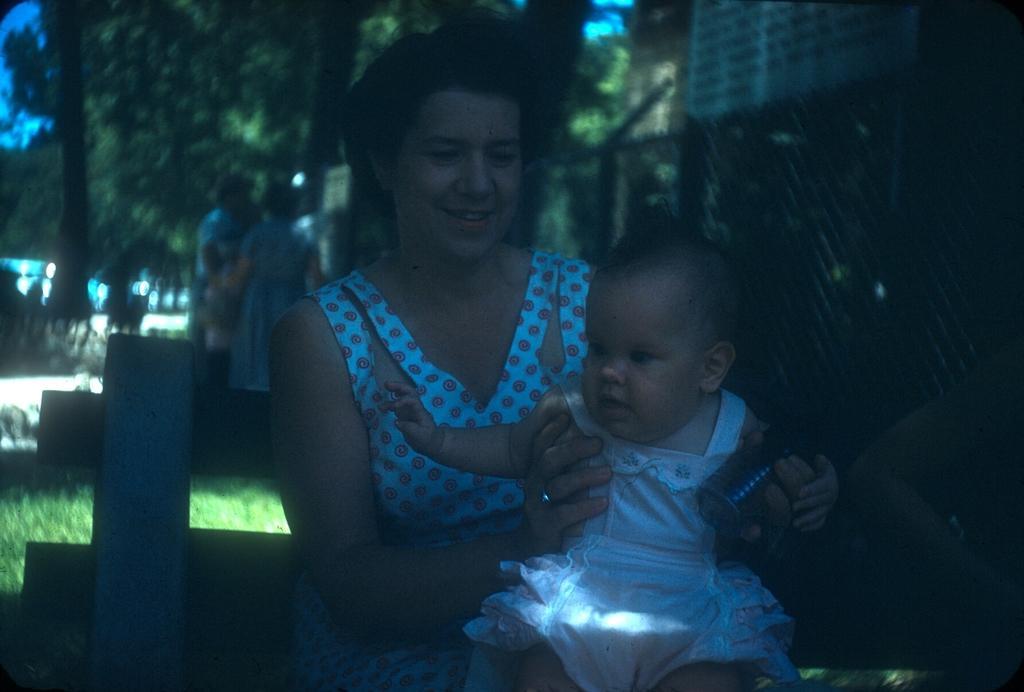Can you describe this image briefly? As we can see in the image there are few people here and there, grass, trees, fence and buildings. The image is little dark. 